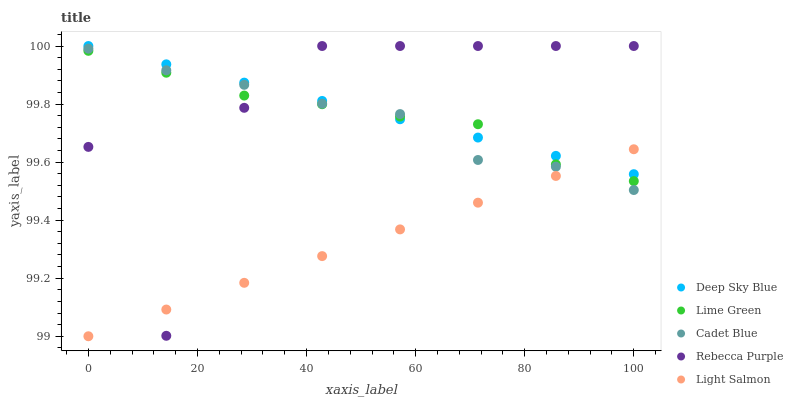Does Light Salmon have the minimum area under the curve?
Answer yes or no. Yes. Does Rebecca Purple have the maximum area under the curve?
Answer yes or no. Yes. Does Cadet Blue have the minimum area under the curve?
Answer yes or no. No. Does Cadet Blue have the maximum area under the curve?
Answer yes or no. No. Is Light Salmon the smoothest?
Answer yes or no. Yes. Is Rebecca Purple the roughest?
Answer yes or no. Yes. Is Cadet Blue the smoothest?
Answer yes or no. No. Is Cadet Blue the roughest?
Answer yes or no. No. Does Light Salmon have the lowest value?
Answer yes or no. Yes. Does Cadet Blue have the lowest value?
Answer yes or no. No. Does Deep Sky Blue have the highest value?
Answer yes or no. Yes. Does Cadet Blue have the highest value?
Answer yes or no. No. Does Light Salmon intersect Lime Green?
Answer yes or no. Yes. Is Light Salmon less than Lime Green?
Answer yes or no. No. Is Light Salmon greater than Lime Green?
Answer yes or no. No. 